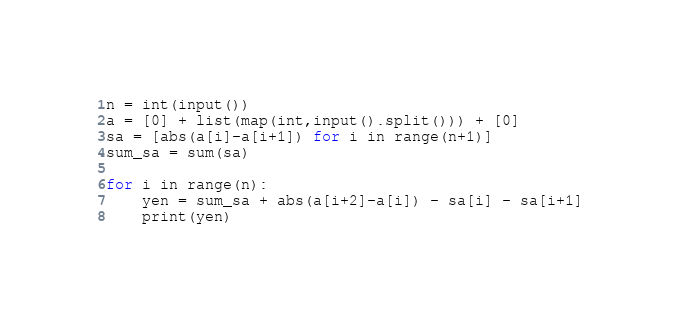Convert code to text. <code><loc_0><loc_0><loc_500><loc_500><_Python_>n = int(input())
a = [0] + list(map(int,input().split())) + [0]
sa = [abs(a[i]-a[i+1]) for i in range(n+1)]
sum_sa = sum(sa)

for i in range(n):
    yen = sum_sa + abs(a[i+2]-a[i]) - sa[i] - sa[i+1]
    print(yen)</code> 